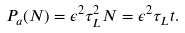<formula> <loc_0><loc_0><loc_500><loc_500>P _ { a } ( N ) = \epsilon ^ { 2 } \tau _ { L } ^ { 2 } N = \epsilon ^ { 2 } \tau _ { L } t .</formula> 